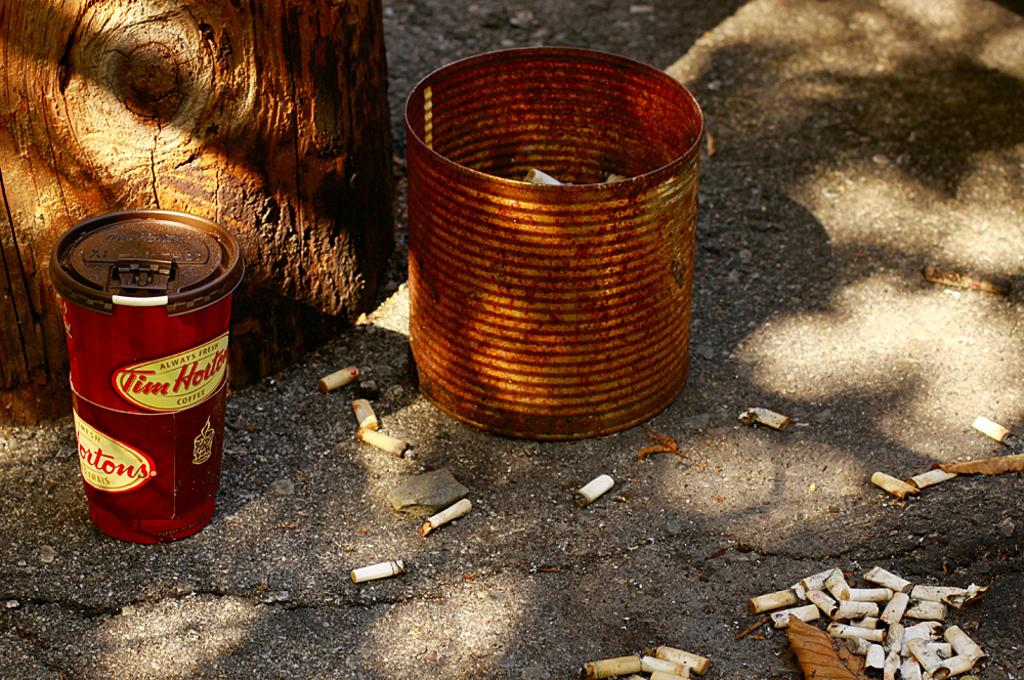<image>
Create a compact narrative representing the image presented. Two red Tim Hortons buckets are stack on top of each other next to a can of discarded cigarettes. 